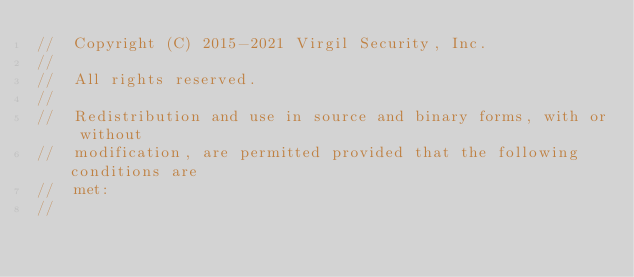<code> <loc_0><loc_0><loc_500><loc_500><_C_>//  Copyright (C) 2015-2021 Virgil Security, Inc.
//
//  All rights reserved.
//
//  Redistribution and use in source and binary forms, with or without
//  modification, are permitted provided that the following conditions are
//  met:
//</code> 